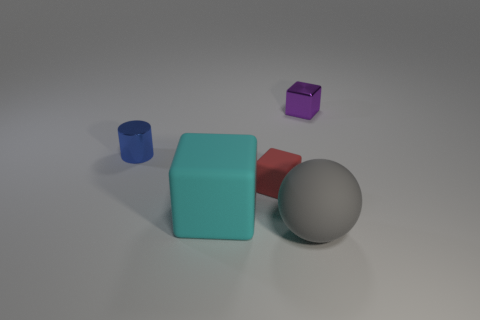What is the color of the small metal thing that is on the left side of the object that is behind the metallic thing in front of the purple shiny cube?
Your answer should be compact. Blue. How many gray spheres have the same size as the metal block?
Offer a very short reply. 0. What color is the tiny shiny object to the right of the blue object?
Offer a terse response. Purple. How many other things are there of the same size as the purple object?
Ensure brevity in your answer.  2. What size is the thing that is to the left of the tiny red thing and to the right of the small blue metal thing?
Ensure brevity in your answer.  Large. Are there any purple metal objects that have the same shape as the cyan rubber thing?
Keep it short and to the point. Yes. What number of objects are tiny red things or cubes that are left of the tiny purple metal block?
Ensure brevity in your answer.  2. What number of other things are made of the same material as the purple object?
Give a very brief answer. 1. What number of things are tiny blue metallic cylinders or large blue cubes?
Provide a short and direct response. 1. Are there more tiny objects right of the tiny red matte thing than metal objects that are right of the small purple thing?
Offer a very short reply. Yes. 